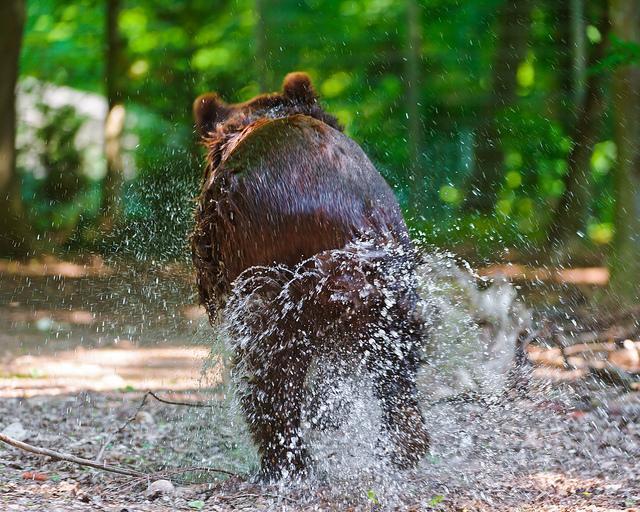How many people are wearing blue jeans?
Give a very brief answer. 0. 